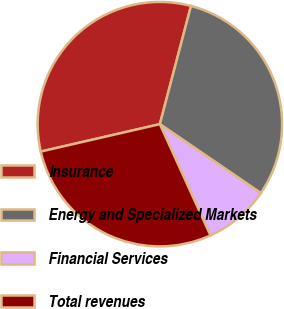Convert chart to OTSL. <chart><loc_0><loc_0><loc_500><loc_500><pie_chart><fcel>Insurance<fcel>Energy and Specialized Markets<fcel>Financial Services<fcel>Total revenues<nl><fcel>32.7%<fcel>30.44%<fcel>8.67%<fcel>28.19%<nl></chart> 